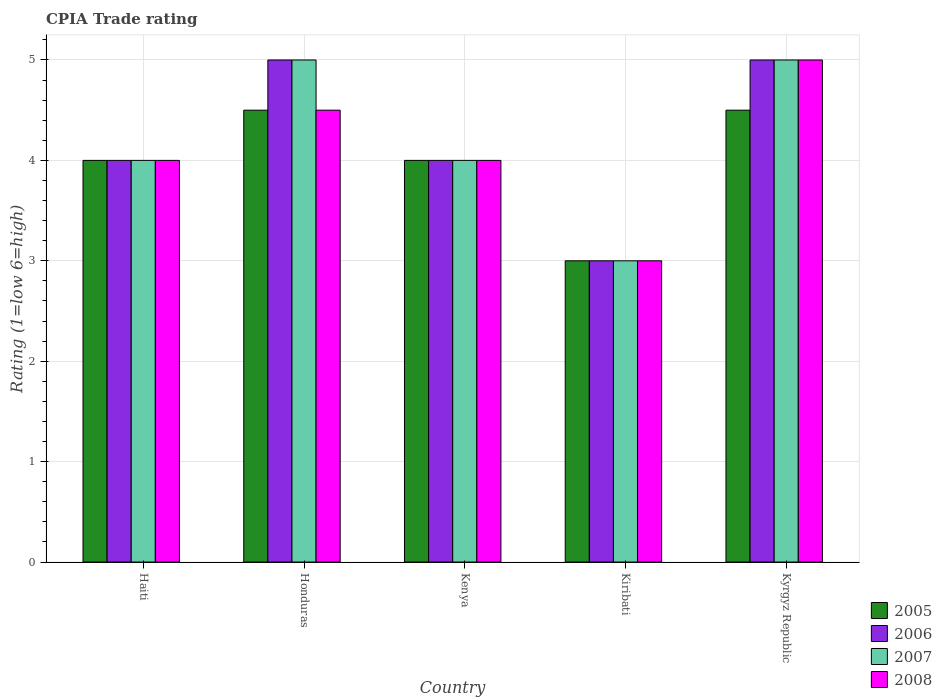How many different coloured bars are there?
Offer a terse response. 4. How many groups of bars are there?
Give a very brief answer. 5. Are the number of bars per tick equal to the number of legend labels?
Offer a very short reply. Yes. How many bars are there on the 4th tick from the left?
Give a very brief answer. 4. What is the label of the 4th group of bars from the left?
Provide a succinct answer. Kiribati. In how many cases, is the number of bars for a given country not equal to the number of legend labels?
Make the answer very short. 0. Across all countries, what is the maximum CPIA rating in 2007?
Make the answer very short. 5. In which country was the CPIA rating in 2007 maximum?
Give a very brief answer. Honduras. In which country was the CPIA rating in 2005 minimum?
Provide a succinct answer. Kiribati. What is the total CPIA rating in 2007 in the graph?
Provide a short and direct response. 21. What is the difference between the CPIA rating in 2005 in Honduras and that in Kyrgyz Republic?
Offer a very short reply. 0. What is the average CPIA rating in 2007 per country?
Make the answer very short. 4.2. What is the difference between the CPIA rating of/in 2005 and CPIA rating of/in 2006 in Haiti?
Provide a short and direct response. 0. In how many countries, is the CPIA rating in 2008 greater than 3.6?
Your response must be concise. 4. What is the ratio of the CPIA rating in 2007 in Honduras to that in Kiribati?
Offer a very short reply. 1.67. Is the difference between the CPIA rating in 2005 in Kenya and Kyrgyz Republic greater than the difference between the CPIA rating in 2006 in Kenya and Kyrgyz Republic?
Your response must be concise. Yes. What is the difference between the highest and the second highest CPIA rating in 2007?
Your answer should be compact. -1. Is the sum of the CPIA rating in 2006 in Honduras and Kiribati greater than the maximum CPIA rating in 2008 across all countries?
Your response must be concise. Yes. Is it the case that in every country, the sum of the CPIA rating in 2008 and CPIA rating in 2007 is greater than the sum of CPIA rating in 2005 and CPIA rating in 2006?
Keep it short and to the point. No. What does the 1st bar from the left in Kenya represents?
Ensure brevity in your answer.  2005. Is it the case that in every country, the sum of the CPIA rating in 2008 and CPIA rating in 2006 is greater than the CPIA rating in 2007?
Offer a very short reply. Yes. Are all the bars in the graph horizontal?
Provide a short and direct response. No. Are the values on the major ticks of Y-axis written in scientific E-notation?
Offer a terse response. No. Where does the legend appear in the graph?
Ensure brevity in your answer.  Bottom right. How many legend labels are there?
Your answer should be compact. 4. How are the legend labels stacked?
Provide a short and direct response. Vertical. What is the title of the graph?
Provide a succinct answer. CPIA Trade rating. Does "1973" appear as one of the legend labels in the graph?
Make the answer very short. No. What is the label or title of the X-axis?
Make the answer very short. Country. What is the label or title of the Y-axis?
Make the answer very short. Rating (1=low 6=high). What is the Rating (1=low 6=high) in 2007 in Haiti?
Keep it short and to the point. 4. What is the Rating (1=low 6=high) in 2006 in Honduras?
Make the answer very short. 5. What is the Rating (1=low 6=high) of 2008 in Kenya?
Ensure brevity in your answer.  4. What is the Rating (1=low 6=high) of 2007 in Kiribati?
Offer a terse response. 3. What is the Rating (1=low 6=high) of 2005 in Kyrgyz Republic?
Provide a succinct answer. 4.5. What is the Rating (1=low 6=high) in 2007 in Kyrgyz Republic?
Offer a very short reply. 5. Across all countries, what is the maximum Rating (1=low 6=high) of 2005?
Your answer should be compact. 4.5. Across all countries, what is the maximum Rating (1=low 6=high) of 2008?
Your answer should be compact. 5. Across all countries, what is the minimum Rating (1=low 6=high) of 2005?
Your response must be concise. 3. Across all countries, what is the minimum Rating (1=low 6=high) in 2007?
Give a very brief answer. 3. Across all countries, what is the minimum Rating (1=low 6=high) in 2008?
Your answer should be compact. 3. What is the total Rating (1=low 6=high) of 2005 in the graph?
Your answer should be compact. 20. What is the total Rating (1=low 6=high) of 2007 in the graph?
Your answer should be very brief. 21. What is the difference between the Rating (1=low 6=high) of 2005 in Haiti and that in Honduras?
Your answer should be very brief. -0.5. What is the difference between the Rating (1=low 6=high) in 2007 in Haiti and that in Honduras?
Make the answer very short. -1. What is the difference between the Rating (1=low 6=high) of 2008 in Haiti and that in Honduras?
Keep it short and to the point. -0.5. What is the difference between the Rating (1=low 6=high) of 2005 in Haiti and that in Kenya?
Make the answer very short. 0. What is the difference between the Rating (1=low 6=high) of 2007 in Haiti and that in Kenya?
Make the answer very short. 0. What is the difference between the Rating (1=low 6=high) of 2008 in Haiti and that in Kenya?
Offer a very short reply. 0. What is the difference between the Rating (1=low 6=high) of 2005 in Haiti and that in Kiribati?
Make the answer very short. 1. What is the difference between the Rating (1=low 6=high) of 2006 in Haiti and that in Kiribati?
Provide a succinct answer. 1. What is the difference between the Rating (1=low 6=high) of 2007 in Haiti and that in Kiribati?
Keep it short and to the point. 1. What is the difference between the Rating (1=low 6=high) in 2008 in Haiti and that in Kiribati?
Ensure brevity in your answer.  1. What is the difference between the Rating (1=low 6=high) of 2005 in Haiti and that in Kyrgyz Republic?
Provide a succinct answer. -0.5. What is the difference between the Rating (1=low 6=high) in 2006 in Haiti and that in Kyrgyz Republic?
Provide a succinct answer. -1. What is the difference between the Rating (1=low 6=high) of 2005 in Honduras and that in Kenya?
Provide a succinct answer. 0.5. What is the difference between the Rating (1=low 6=high) of 2008 in Honduras and that in Kenya?
Provide a succinct answer. 0.5. What is the difference between the Rating (1=low 6=high) of 2007 in Honduras and that in Kiribati?
Make the answer very short. 2. What is the difference between the Rating (1=low 6=high) of 2005 in Honduras and that in Kyrgyz Republic?
Offer a very short reply. 0. What is the difference between the Rating (1=low 6=high) of 2006 in Honduras and that in Kyrgyz Republic?
Keep it short and to the point. 0. What is the difference between the Rating (1=low 6=high) in 2005 in Kenya and that in Kiribati?
Your answer should be very brief. 1. What is the difference between the Rating (1=low 6=high) in 2008 in Kenya and that in Kiribati?
Ensure brevity in your answer.  1. What is the difference between the Rating (1=low 6=high) of 2006 in Kenya and that in Kyrgyz Republic?
Your answer should be very brief. -1. What is the difference between the Rating (1=low 6=high) in 2008 in Kenya and that in Kyrgyz Republic?
Provide a short and direct response. -1. What is the difference between the Rating (1=low 6=high) of 2005 in Haiti and the Rating (1=low 6=high) of 2006 in Honduras?
Make the answer very short. -1. What is the difference between the Rating (1=low 6=high) in 2005 in Haiti and the Rating (1=low 6=high) in 2007 in Honduras?
Keep it short and to the point. -1. What is the difference between the Rating (1=low 6=high) in 2006 in Haiti and the Rating (1=low 6=high) in 2007 in Honduras?
Provide a short and direct response. -1. What is the difference between the Rating (1=low 6=high) of 2006 in Haiti and the Rating (1=low 6=high) of 2008 in Honduras?
Keep it short and to the point. -0.5. What is the difference between the Rating (1=low 6=high) of 2005 in Haiti and the Rating (1=low 6=high) of 2006 in Kenya?
Provide a short and direct response. 0. What is the difference between the Rating (1=low 6=high) in 2006 in Haiti and the Rating (1=low 6=high) in 2007 in Kenya?
Your response must be concise. 0. What is the difference between the Rating (1=low 6=high) of 2006 in Haiti and the Rating (1=low 6=high) of 2008 in Kenya?
Provide a succinct answer. 0. What is the difference between the Rating (1=low 6=high) of 2007 in Haiti and the Rating (1=low 6=high) of 2008 in Kenya?
Your answer should be compact. 0. What is the difference between the Rating (1=low 6=high) in 2005 in Haiti and the Rating (1=low 6=high) in 2006 in Kiribati?
Your response must be concise. 1. What is the difference between the Rating (1=low 6=high) of 2006 in Haiti and the Rating (1=low 6=high) of 2007 in Kiribati?
Your response must be concise. 1. What is the difference between the Rating (1=low 6=high) of 2006 in Haiti and the Rating (1=low 6=high) of 2008 in Kiribati?
Make the answer very short. 1. What is the difference between the Rating (1=low 6=high) of 2007 in Haiti and the Rating (1=low 6=high) of 2008 in Kyrgyz Republic?
Your answer should be very brief. -1. What is the difference between the Rating (1=low 6=high) of 2005 in Honduras and the Rating (1=low 6=high) of 2007 in Kenya?
Your response must be concise. 0.5. What is the difference between the Rating (1=low 6=high) of 2005 in Honduras and the Rating (1=low 6=high) of 2008 in Kenya?
Offer a terse response. 0.5. What is the difference between the Rating (1=low 6=high) in 2006 in Honduras and the Rating (1=low 6=high) in 2007 in Kenya?
Your answer should be very brief. 1. What is the difference between the Rating (1=low 6=high) of 2007 in Honduras and the Rating (1=low 6=high) of 2008 in Kenya?
Make the answer very short. 1. What is the difference between the Rating (1=low 6=high) of 2005 in Honduras and the Rating (1=low 6=high) of 2006 in Kiribati?
Your answer should be compact. 1.5. What is the difference between the Rating (1=low 6=high) in 2006 in Honduras and the Rating (1=low 6=high) in 2007 in Kiribati?
Offer a terse response. 2. What is the difference between the Rating (1=low 6=high) in 2005 in Honduras and the Rating (1=low 6=high) in 2007 in Kyrgyz Republic?
Keep it short and to the point. -0.5. What is the difference between the Rating (1=low 6=high) of 2006 in Honduras and the Rating (1=low 6=high) of 2008 in Kyrgyz Republic?
Provide a succinct answer. 0. What is the difference between the Rating (1=low 6=high) of 2007 in Honduras and the Rating (1=low 6=high) of 2008 in Kyrgyz Republic?
Your answer should be very brief. 0. What is the difference between the Rating (1=low 6=high) of 2005 in Kenya and the Rating (1=low 6=high) of 2006 in Kiribati?
Your answer should be compact. 1. What is the difference between the Rating (1=low 6=high) of 2005 in Kenya and the Rating (1=low 6=high) of 2007 in Kiribati?
Your answer should be very brief. 1. What is the difference between the Rating (1=low 6=high) of 2006 in Kenya and the Rating (1=low 6=high) of 2007 in Kiribati?
Your response must be concise. 1. What is the difference between the Rating (1=low 6=high) in 2007 in Kenya and the Rating (1=low 6=high) in 2008 in Kiribati?
Your response must be concise. 1. What is the difference between the Rating (1=low 6=high) of 2005 in Kenya and the Rating (1=low 6=high) of 2007 in Kyrgyz Republic?
Provide a short and direct response. -1. What is the difference between the Rating (1=low 6=high) in 2005 in Kenya and the Rating (1=low 6=high) in 2008 in Kyrgyz Republic?
Make the answer very short. -1. What is the difference between the Rating (1=low 6=high) in 2006 in Kenya and the Rating (1=low 6=high) in 2007 in Kyrgyz Republic?
Keep it short and to the point. -1. What is the difference between the Rating (1=low 6=high) of 2006 in Kenya and the Rating (1=low 6=high) of 2008 in Kyrgyz Republic?
Your answer should be very brief. -1. What is the difference between the Rating (1=low 6=high) in 2007 in Kenya and the Rating (1=low 6=high) in 2008 in Kyrgyz Republic?
Provide a short and direct response. -1. What is the difference between the Rating (1=low 6=high) in 2007 in Kiribati and the Rating (1=low 6=high) in 2008 in Kyrgyz Republic?
Provide a succinct answer. -2. What is the average Rating (1=low 6=high) of 2007 per country?
Your answer should be compact. 4.2. What is the average Rating (1=low 6=high) of 2008 per country?
Your response must be concise. 4.1. What is the difference between the Rating (1=low 6=high) in 2005 and Rating (1=low 6=high) in 2006 in Haiti?
Your answer should be compact. 0. What is the difference between the Rating (1=low 6=high) of 2005 and Rating (1=low 6=high) of 2007 in Haiti?
Your answer should be compact. 0. What is the difference between the Rating (1=low 6=high) of 2005 and Rating (1=low 6=high) of 2008 in Haiti?
Ensure brevity in your answer.  0. What is the difference between the Rating (1=low 6=high) of 2007 and Rating (1=low 6=high) of 2008 in Haiti?
Keep it short and to the point. 0. What is the difference between the Rating (1=low 6=high) in 2005 and Rating (1=low 6=high) in 2006 in Honduras?
Provide a succinct answer. -0.5. What is the difference between the Rating (1=low 6=high) of 2005 and Rating (1=low 6=high) of 2007 in Honduras?
Ensure brevity in your answer.  -0.5. What is the difference between the Rating (1=low 6=high) in 2005 and Rating (1=low 6=high) in 2008 in Honduras?
Your response must be concise. 0. What is the difference between the Rating (1=low 6=high) of 2006 and Rating (1=low 6=high) of 2007 in Honduras?
Your response must be concise. 0. What is the difference between the Rating (1=low 6=high) in 2007 and Rating (1=low 6=high) in 2008 in Honduras?
Make the answer very short. 0.5. What is the difference between the Rating (1=low 6=high) in 2005 and Rating (1=low 6=high) in 2007 in Kenya?
Offer a very short reply. 0. What is the difference between the Rating (1=low 6=high) in 2006 and Rating (1=low 6=high) in 2007 in Kenya?
Your answer should be compact. 0. What is the difference between the Rating (1=low 6=high) in 2006 and Rating (1=low 6=high) in 2008 in Kenya?
Make the answer very short. 0. What is the difference between the Rating (1=low 6=high) in 2006 and Rating (1=low 6=high) in 2008 in Kiribati?
Provide a succinct answer. 0. What is the difference between the Rating (1=low 6=high) in 2005 and Rating (1=low 6=high) in 2007 in Kyrgyz Republic?
Make the answer very short. -0.5. What is the difference between the Rating (1=low 6=high) of 2006 and Rating (1=low 6=high) of 2008 in Kyrgyz Republic?
Offer a terse response. 0. What is the difference between the Rating (1=low 6=high) in 2007 and Rating (1=low 6=high) in 2008 in Kyrgyz Republic?
Ensure brevity in your answer.  0. What is the ratio of the Rating (1=low 6=high) of 2005 in Haiti to that in Honduras?
Keep it short and to the point. 0.89. What is the ratio of the Rating (1=low 6=high) of 2006 in Haiti to that in Kenya?
Offer a very short reply. 1. What is the ratio of the Rating (1=low 6=high) of 2005 in Haiti to that in Kiribati?
Your response must be concise. 1.33. What is the ratio of the Rating (1=low 6=high) of 2006 in Haiti to that in Kiribati?
Give a very brief answer. 1.33. What is the ratio of the Rating (1=low 6=high) in 2007 in Haiti to that in Kiribati?
Make the answer very short. 1.33. What is the ratio of the Rating (1=low 6=high) in 2008 in Haiti to that in Kiribati?
Give a very brief answer. 1.33. What is the ratio of the Rating (1=low 6=high) in 2006 in Haiti to that in Kyrgyz Republic?
Offer a terse response. 0.8. What is the ratio of the Rating (1=low 6=high) in 2005 in Honduras to that in Kenya?
Keep it short and to the point. 1.12. What is the ratio of the Rating (1=low 6=high) of 2007 in Honduras to that in Kenya?
Your response must be concise. 1.25. What is the ratio of the Rating (1=low 6=high) of 2008 in Honduras to that in Kenya?
Your answer should be very brief. 1.12. What is the ratio of the Rating (1=low 6=high) in 2008 in Honduras to that in Kiribati?
Give a very brief answer. 1.5. What is the ratio of the Rating (1=low 6=high) of 2006 in Honduras to that in Kyrgyz Republic?
Your answer should be very brief. 1. What is the ratio of the Rating (1=low 6=high) of 2008 in Honduras to that in Kyrgyz Republic?
Offer a very short reply. 0.9. What is the ratio of the Rating (1=low 6=high) of 2006 in Kenya to that in Kiribati?
Your response must be concise. 1.33. What is the ratio of the Rating (1=low 6=high) of 2007 in Kenya to that in Kiribati?
Provide a short and direct response. 1.33. What is the ratio of the Rating (1=low 6=high) in 2008 in Kenya to that in Kyrgyz Republic?
Your answer should be very brief. 0.8. What is the ratio of the Rating (1=low 6=high) in 2005 in Kiribati to that in Kyrgyz Republic?
Offer a terse response. 0.67. What is the ratio of the Rating (1=low 6=high) of 2007 in Kiribati to that in Kyrgyz Republic?
Your response must be concise. 0.6. What is the ratio of the Rating (1=low 6=high) of 2008 in Kiribati to that in Kyrgyz Republic?
Give a very brief answer. 0.6. What is the difference between the highest and the second highest Rating (1=low 6=high) in 2005?
Offer a terse response. 0. What is the difference between the highest and the second highest Rating (1=low 6=high) in 2008?
Your answer should be very brief. 0.5. What is the difference between the highest and the lowest Rating (1=low 6=high) in 2005?
Give a very brief answer. 1.5. What is the difference between the highest and the lowest Rating (1=low 6=high) in 2007?
Give a very brief answer. 2. What is the difference between the highest and the lowest Rating (1=low 6=high) of 2008?
Provide a succinct answer. 2. 